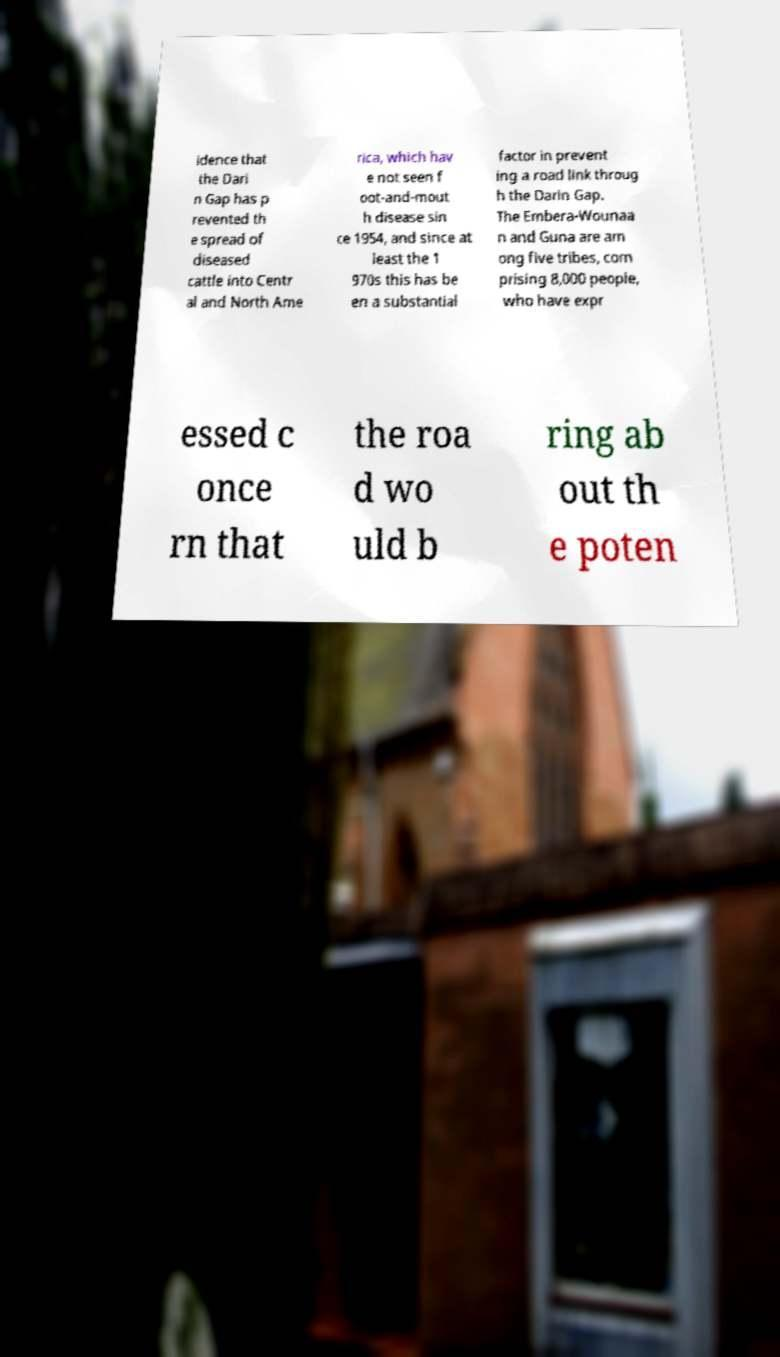Could you extract and type out the text from this image? idence that the Dari n Gap has p revented th e spread of diseased cattle into Centr al and North Ame rica, which hav e not seen f oot-and-mout h disease sin ce 1954, and since at least the 1 970s this has be en a substantial factor in prevent ing a road link throug h the Darin Gap. The Embera-Wounaa n and Guna are am ong five tribes, com prising 8,000 people, who have expr essed c once rn that the roa d wo uld b ring ab out th e poten 